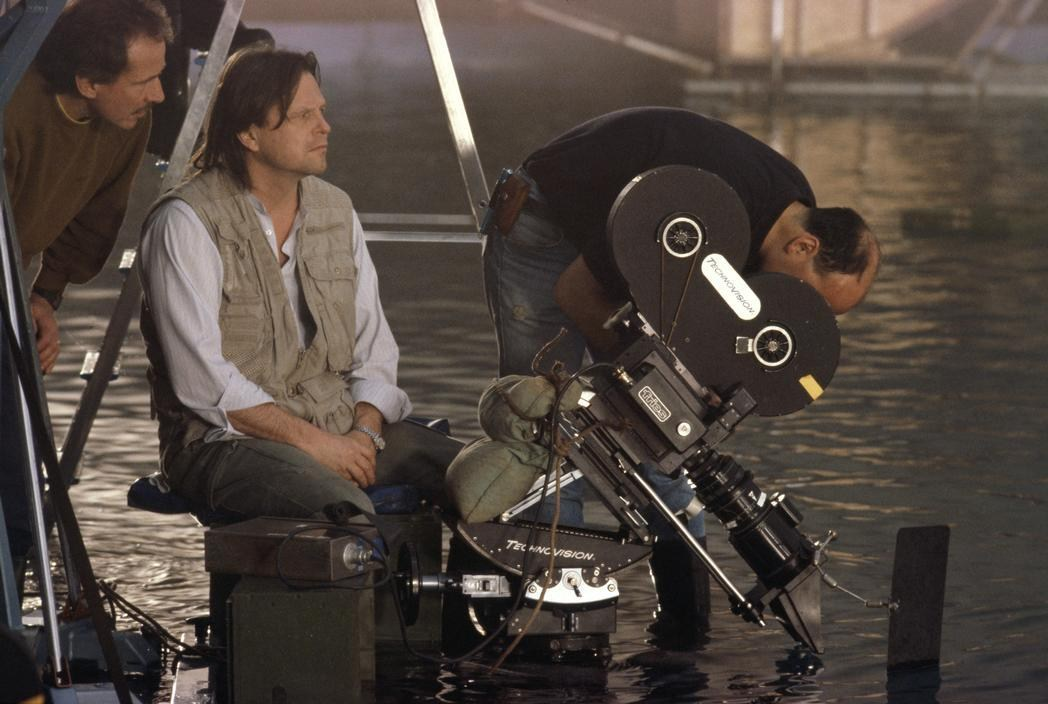What kind of scene requires this type of camera setup? This type of camera setup, with a Panavision camera being used near and partially in the water, is often required for scenes that involve close interaction with water. It could be used for filming underwater scenes or scenes that take place in or around water, such as a dramatic river crossing, a flooded area, or even a sequence underwater. This setup is designed to capture the unique dynamics and reflections created by water, providing a visually stunning experience for the audience. Could this scene be for a specific genre of film? Absolutely. The scene could be part of a variety of genres, but it is most commonly associated with action, thriller, or adventure films where water encounters play a significant role. For example, it could be an intense action film involving a harrowing escape through a flooded urban area, a thriller with a dramatic river rescue, or an adventure film featuring a treacherous journey across water. The setting and the elaborate camera setup suggest high stakes and a visually compelling narrative that engages the audience. 